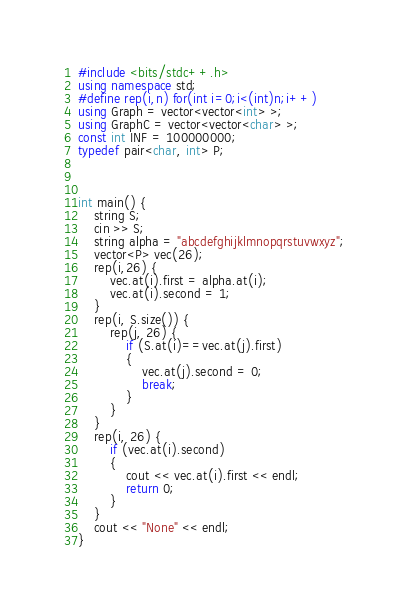<code> <loc_0><loc_0><loc_500><loc_500><_C++_>#include <bits/stdc++.h>
using namespace std;
#define rep(i,n) for(int i=0;i<(int)n;i++)
using Graph = vector<vector<int> >;
using GraphC = vector<vector<char> >;
const int INF = 100000000;
typedef pair<char, int> P;



int main() {
	string S;
	cin >> S;
	string alpha = "abcdefghijklmnopqrstuvwxyz";
	vector<P> vec(26);
	rep(i,26) {
		vec.at(i).first = alpha.at(i);
		vec.at(i).second = 1;
	}
	rep(i, S.size()) {
		rep(j, 26) {
			if (S.at(i)==vec.at(j).first)
			{
				vec.at(j).second = 0;
				break;
			}
		}
	}
	rep(i, 26) {
		if (vec.at(i).second)
		{
			cout << vec.at(i).first << endl;
			return 0;
		}
	}
	cout << "None" << endl;
}</code> 